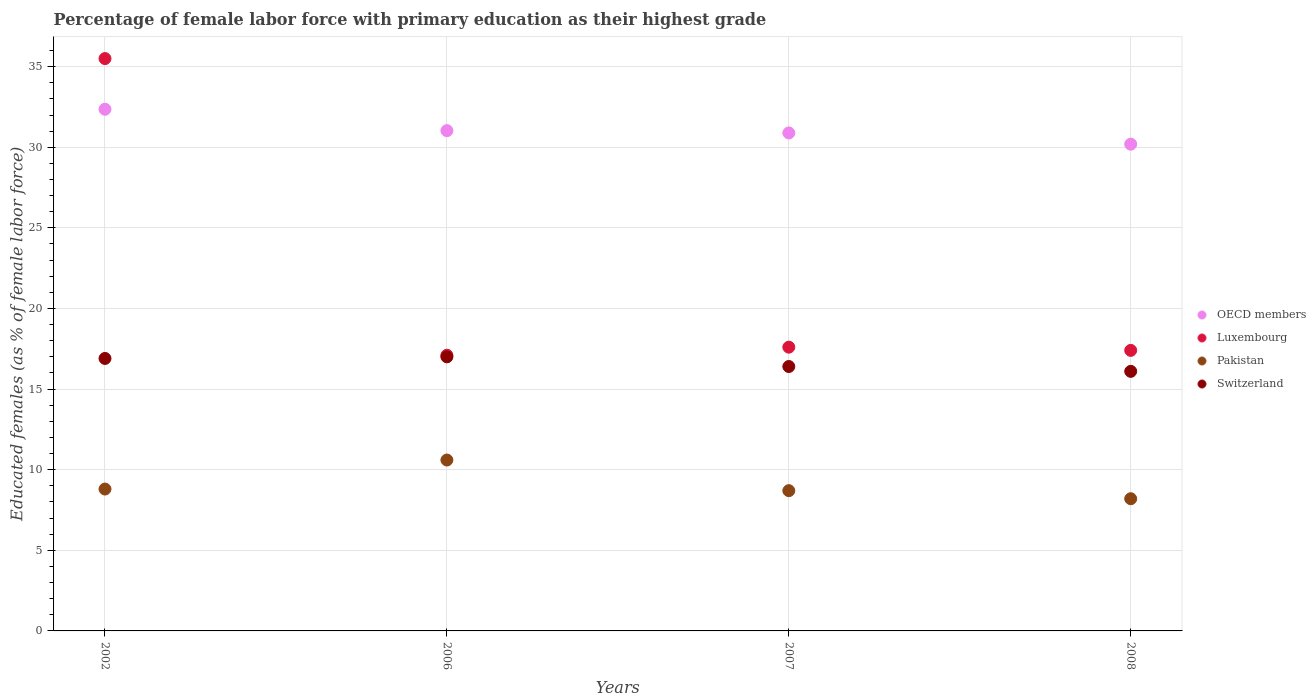What is the percentage of female labor force with primary education in Pakistan in 2006?
Make the answer very short. 10.6. Across all years, what is the maximum percentage of female labor force with primary education in Pakistan?
Your answer should be very brief. 10.6. Across all years, what is the minimum percentage of female labor force with primary education in Luxembourg?
Your response must be concise. 17.1. In which year was the percentage of female labor force with primary education in OECD members maximum?
Offer a terse response. 2002. What is the total percentage of female labor force with primary education in Switzerland in the graph?
Keep it short and to the point. 66.4. What is the difference between the percentage of female labor force with primary education in Pakistan in 2006 and that in 2008?
Keep it short and to the point. 2.4. What is the difference between the percentage of female labor force with primary education in OECD members in 2006 and the percentage of female labor force with primary education in Luxembourg in 2008?
Give a very brief answer. 13.63. What is the average percentage of female labor force with primary education in Luxembourg per year?
Make the answer very short. 21.9. In the year 2002, what is the difference between the percentage of female labor force with primary education in Pakistan and percentage of female labor force with primary education in Switzerland?
Offer a terse response. -8.1. In how many years, is the percentage of female labor force with primary education in OECD members greater than 18 %?
Your answer should be compact. 4. What is the ratio of the percentage of female labor force with primary education in OECD members in 2006 to that in 2007?
Make the answer very short. 1. Is the percentage of female labor force with primary education in Luxembourg in 2007 less than that in 2008?
Keep it short and to the point. No. What is the difference between the highest and the second highest percentage of female labor force with primary education in Switzerland?
Provide a succinct answer. 0.1. What is the difference between the highest and the lowest percentage of female labor force with primary education in OECD members?
Your answer should be very brief. 2.17. Is the percentage of female labor force with primary education in Pakistan strictly greater than the percentage of female labor force with primary education in Luxembourg over the years?
Provide a short and direct response. No. Is the percentage of female labor force with primary education in Luxembourg strictly less than the percentage of female labor force with primary education in Switzerland over the years?
Provide a short and direct response. No. How many dotlines are there?
Offer a very short reply. 4. How many years are there in the graph?
Provide a short and direct response. 4. What is the difference between two consecutive major ticks on the Y-axis?
Give a very brief answer. 5. Are the values on the major ticks of Y-axis written in scientific E-notation?
Offer a terse response. No. Does the graph contain any zero values?
Offer a terse response. No. Does the graph contain grids?
Give a very brief answer. Yes. What is the title of the graph?
Offer a terse response. Percentage of female labor force with primary education as their highest grade. What is the label or title of the Y-axis?
Provide a short and direct response. Educated females (as % of female labor force). What is the Educated females (as % of female labor force) in OECD members in 2002?
Provide a short and direct response. 32.36. What is the Educated females (as % of female labor force) in Luxembourg in 2002?
Your answer should be compact. 35.5. What is the Educated females (as % of female labor force) in Pakistan in 2002?
Offer a very short reply. 8.8. What is the Educated females (as % of female labor force) in Switzerland in 2002?
Your response must be concise. 16.9. What is the Educated females (as % of female labor force) of OECD members in 2006?
Ensure brevity in your answer.  31.03. What is the Educated females (as % of female labor force) in Luxembourg in 2006?
Offer a very short reply. 17.1. What is the Educated females (as % of female labor force) of Pakistan in 2006?
Your response must be concise. 10.6. What is the Educated females (as % of female labor force) in OECD members in 2007?
Give a very brief answer. 30.89. What is the Educated females (as % of female labor force) in Luxembourg in 2007?
Offer a very short reply. 17.6. What is the Educated females (as % of female labor force) of Pakistan in 2007?
Offer a very short reply. 8.7. What is the Educated females (as % of female labor force) of Switzerland in 2007?
Your answer should be compact. 16.4. What is the Educated females (as % of female labor force) of OECD members in 2008?
Give a very brief answer. 30.19. What is the Educated females (as % of female labor force) in Luxembourg in 2008?
Keep it short and to the point. 17.4. What is the Educated females (as % of female labor force) in Pakistan in 2008?
Your response must be concise. 8.2. What is the Educated females (as % of female labor force) in Switzerland in 2008?
Provide a succinct answer. 16.1. Across all years, what is the maximum Educated females (as % of female labor force) in OECD members?
Keep it short and to the point. 32.36. Across all years, what is the maximum Educated females (as % of female labor force) in Luxembourg?
Offer a terse response. 35.5. Across all years, what is the maximum Educated females (as % of female labor force) of Pakistan?
Provide a short and direct response. 10.6. Across all years, what is the maximum Educated females (as % of female labor force) of Switzerland?
Your response must be concise. 17. Across all years, what is the minimum Educated females (as % of female labor force) of OECD members?
Offer a very short reply. 30.19. Across all years, what is the minimum Educated females (as % of female labor force) in Luxembourg?
Your response must be concise. 17.1. Across all years, what is the minimum Educated females (as % of female labor force) of Pakistan?
Ensure brevity in your answer.  8.2. Across all years, what is the minimum Educated females (as % of female labor force) in Switzerland?
Offer a very short reply. 16.1. What is the total Educated females (as % of female labor force) of OECD members in the graph?
Ensure brevity in your answer.  124.47. What is the total Educated females (as % of female labor force) in Luxembourg in the graph?
Keep it short and to the point. 87.6. What is the total Educated females (as % of female labor force) in Pakistan in the graph?
Make the answer very short. 36.3. What is the total Educated females (as % of female labor force) of Switzerland in the graph?
Your answer should be compact. 66.4. What is the difference between the Educated females (as % of female labor force) of OECD members in 2002 and that in 2006?
Keep it short and to the point. 1.33. What is the difference between the Educated females (as % of female labor force) in Switzerland in 2002 and that in 2006?
Your answer should be very brief. -0.1. What is the difference between the Educated females (as % of female labor force) of OECD members in 2002 and that in 2007?
Your response must be concise. 1.47. What is the difference between the Educated females (as % of female labor force) of Pakistan in 2002 and that in 2007?
Give a very brief answer. 0.1. What is the difference between the Educated females (as % of female labor force) in Switzerland in 2002 and that in 2007?
Keep it short and to the point. 0.5. What is the difference between the Educated females (as % of female labor force) in OECD members in 2002 and that in 2008?
Offer a very short reply. 2.17. What is the difference between the Educated females (as % of female labor force) in Luxembourg in 2002 and that in 2008?
Provide a succinct answer. 18.1. What is the difference between the Educated females (as % of female labor force) of Switzerland in 2002 and that in 2008?
Keep it short and to the point. 0.8. What is the difference between the Educated females (as % of female labor force) of OECD members in 2006 and that in 2007?
Provide a short and direct response. 0.14. What is the difference between the Educated females (as % of female labor force) in Luxembourg in 2006 and that in 2007?
Provide a short and direct response. -0.5. What is the difference between the Educated females (as % of female labor force) of Pakistan in 2006 and that in 2007?
Provide a succinct answer. 1.9. What is the difference between the Educated females (as % of female labor force) in Switzerland in 2006 and that in 2007?
Offer a terse response. 0.6. What is the difference between the Educated females (as % of female labor force) of OECD members in 2006 and that in 2008?
Provide a succinct answer. 0.84. What is the difference between the Educated females (as % of female labor force) in Luxembourg in 2006 and that in 2008?
Your response must be concise. -0.3. What is the difference between the Educated females (as % of female labor force) of OECD members in 2007 and that in 2008?
Provide a succinct answer. 0.7. What is the difference between the Educated females (as % of female labor force) in Luxembourg in 2007 and that in 2008?
Give a very brief answer. 0.2. What is the difference between the Educated females (as % of female labor force) of Pakistan in 2007 and that in 2008?
Provide a short and direct response. 0.5. What is the difference between the Educated females (as % of female labor force) in OECD members in 2002 and the Educated females (as % of female labor force) in Luxembourg in 2006?
Offer a very short reply. 15.26. What is the difference between the Educated females (as % of female labor force) of OECD members in 2002 and the Educated females (as % of female labor force) of Pakistan in 2006?
Your response must be concise. 21.76. What is the difference between the Educated females (as % of female labor force) in OECD members in 2002 and the Educated females (as % of female labor force) in Switzerland in 2006?
Provide a short and direct response. 15.36. What is the difference between the Educated females (as % of female labor force) of Luxembourg in 2002 and the Educated females (as % of female labor force) of Pakistan in 2006?
Your answer should be compact. 24.9. What is the difference between the Educated females (as % of female labor force) of Luxembourg in 2002 and the Educated females (as % of female labor force) of Switzerland in 2006?
Your answer should be compact. 18.5. What is the difference between the Educated females (as % of female labor force) of Pakistan in 2002 and the Educated females (as % of female labor force) of Switzerland in 2006?
Ensure brevity in your answer.  -8.2. What is the difference between the Educated females (as % of female labor force) of OECD members in 2002 and the Educated females (as % of female labor force) of Luxembourg in 2007?
Make the answer very short. 14.76. What is the difference between the Educated females (as % of female labor force) of OECD members in 2002 and the Educated females (as % of female labor force) of Pakistan in 2007?
Your answer should be very brief. 23.66. What is the difference between the Educated females (as % of female labor force) of OECD members in 2002 and the Educated females (as % of female labor force) of Switzerland in 2007?
Make the answer very short. 15.96. What is the difference between the Educated females (as % of female labor force) in Luxembourg in 2002 and the Educated females (as % of female labor force) in Pakistan in 2007?
Your response must be concise. 26.8. What is the difference between the Educated females (as % of female labor force) in Pakistan in 2002 and the Educated females (as % of female labor force) in Switzerland in 2007?
Your response must be concise. -7.6. What is the difference between the Educated females (as % of female labor force) of OECD members in 2002 and the Educated females (as % of female labor force) of Luxembourg in 2008?
Your answer should be very brief. 14.96. What is the difference between the Educated females (as % of female labor force) of OECD members in 2002 and the Educated females (as % of female labor force) of Pakistan in 2008?
Ensure brevity in your answer.  24.16. What is the difference between the Educated females (as % of female labor force) in OECD members in 2002 and the Educated females (as % of female labor force) in Switzerland in 2008?
Your answer should be compact. 16.26. What is the difference between the Educated females (as % of female labor force) in Luxembourg in 2002 and the Educated females (as % of female labor force) in Pakistan in 2008?
Your response must be concise. 27.3. What is the difference between the Educated females (as % of female labor force) in Pakistan in 2002 and the Educated females (as % of female labor force) in Switzerland in 2008?
Keep it short and to the point. -7.3. What is the difference between the Educated females (as % of female labor force) in OECD members in 2006 and the Educated females (as % of female labor force) in Luxembourg in 2007?
Your response must be concise. 13.43. What is the difference between the Educated females (as % of female labor force) in OECD members in 2006 and the Educated females (as % of female labor force) in Pakistan in 2007?
Give a very brief answer. 22.33. What is the difference between the Educated females (as % of female labor force) of OECD members in 2006 and the Educated females (as % of female labor force) of Switzerland in 2007?
Make the answer very short. 14.63. What is the difference between the Educated females (as % of female labor force) in Luxembourg in 2006 and the Educated females (as % of female labor force) in Pakistan in 2007?
Offer a terse response. 8.4. What is the difference between the Educated females (as % of female labor force) in OECD members in 2006 and the Educated females (as % of female labor force) in Luxembourg in 2008?
Offer a terse response. 13.63. What is the difference between the Educated females (as % of female labor force) of OECD members in 2006 and the Educated females (as % of female labor force) of Pakistan in 2008?
Offer a very short reply. 22.83. What is the difference between the Educated females (as % of female labor force) of OECD members in 2006 and the Educated females (as % of female labor force) of Switzerland in 2008?
Provide a short and direct response. 14.93. What is the difference between the Educated females (as % of female labor force) of Luxembourg in 2006 and the Educated females (as % of female labor force) of Switzerland in 2008?
Give a very brief answer. 1. What is the difference between the Educated females (as % of female labor force) of Pakistan in 2006 and the Educated females (as % of female labor force) of Switzerland in 2008?
Keep it short and to the point. -5.5. What is the difference between the Educated females (as % of female labor force) of OECD members in 2007 and the Educated females (as % of female labor force) of Luxembourg in 2008?
Your answer should be compact. 13.49. What is the difference between the Educated females (as % of female labor force) in OECD members in 2007 and the Educated females (as % of female labor force) in Pakistan in 2008?
Provide a succinct answer. 22.69. What is the difference between the Educated females (as % of female labor force) in OECD members in 2007 and the Educated females (as % of female labor force) in Switzerland in 2008?
Give a very brief answer. 14.79. What is the difference between the Educated females (as % of female labor force) in Luxembourg in 2007 and the Educated females (as % of female labor force) in Switzerland in 2008?
Give a very brief answer. 1.5. What is the difference between the Educated females (as % of female labor force) in Pakistan in 2007 and the Educated females (as % of female labor force) in Switzerland in 2008?
Provide a succinct answer. -7.4. What is the average Educated females (as % of female labor force) in OECD members per year?
Offer a very short reply. 31.12. What is the average Educated females (as % of female labor force) in Luxembourg per year?
Your response must be concise. 21.9. What is the average Educated females (as % of female labor force) of Pakistan per year?
Offer a very short reply. 9.07. In the year 2002, what is the difference between the Educated females (as % of female labor force) in OECD members and Educated females (as % of female labor force) in Luxembourg?
Offer a terse response. -3.14. In the year 2002, what is the difference between the Educated females (as % of female labor force) in OECD members and Educated females (as % of female labor force) in Pakistan?
Make the answer very short. 23.56. In the year 2002, what is the difference between the Educated females (as % of female labor force) of OECD members and Educated females (as % of female labor force) of Switzerland?
Your response must be concise. 15.46. In the year 2002, what is the difference between the Educated females (as % of female labor force) of Luxembourg and Educated females (as % of female labor force) of Pakistan?
Make the answer very short. 26.7. In the year 2006, what is the difference between the Educated females (as % of female labor force) in OECD members and Educated females (as % of female labor force) in Luxembourg?
Your answer should be very brief. 13.93. In the year 2006, what is the difference between the Educated females (as % of female labor force) in OECD members and Educated females (as % of female labor force) in Pakistan?
Your answer should be compact. 20.43. In the year 2006, what is the difference between the Educated females (as % of female labor force) in OECD members and Educated females (as % of female labor force) in Switzerland?
Make the answer very short. 14.03. In the year 2006, what is the difference between the Educated females (as % of female labor force) in Luxembourg and Educated females (as % of female labor force) in Pakistan?
Provide a succinct answer. 6.5. In the year 2007, what is the difference between the Educated females (as % of female labor force) of OECD members and Educated females (as % of female labor force) of Luxembourg?
Provide a short and direct response. 13.29. In the year 2007, what is the difference between the Educated females (as % of female labor force) in OECD members and Educated females (as % of female labor force) in Pakistan?
Provide a succinct answer. 22.19. In the year 2007, what is the difference between the Educated females (as % of female labor force) in OECD members and Educated females (as % of female labor force) in Switzerland?
Your answer should be compact. 14.49. In the year 2007, what is the difference between the Educated females (as % of female labor force) in Luxembourg and Educated females (as % of female labor force) in Switzerland?
Provide a short and direct response. 1.2. In the year 2007, what is the difference between the Educated females (as % of female labor force) in Pakistan and Educated females (as % of female labor force) in Switzerland?
Make the answer very short. -7.7. In the year 2008, what is the difference between the Educated females (as % of female labor force) of OECD members and Educated females (as % of female labor force) of Luxembourg?
Keep it short and to the point. 12.79. In the year 2008, what is the difference between the Educated females (as % of female labor force) in OECD members and Educated females (as % of female labor force) in Pakistan?
Offer a terse response. 21.99. In the year 2008, what is the difference between the Educated females (as % of female labor force) in OECD members and Educated females (as % of female labor force) in Switzerland?
Keep it short and to the point. 14.09. In the year 2008, what is the difference between the Educated females (as % of female labor force) of Luxembourg and Educated females (as % of female labor force) of Pakistan?
Offer a very short reply. 9.2. In the year 2008, what is the difference between the Educated females (as % of female labor force) of Luxembourg and Educated females (as % of female labor force) of Switzerland?
Offer a terse response. 1.3. In the year 2008, what is the difference between the Educated females (as % of female labor force) in Pakistan and Educated females (as % of female labor force) in Switzerland?
Your response must be concise. -7.9. What is the ratio of the Educated females (as % of female labor force) of OECD members in 2002 to that in 2006?
Keep it short and to the point. 1.04. What is the ratio of the Educated females (as % of female labor force) in Luxembourg in 2002 to that in 2006?
Keep it short and to the point. 2.08. What is the ratio of the Educated females (as % of female labor force) in Pakistan in 2002 to that in 2006?
Your response must be concise. 0.83. What is the ratio of the Educated females (as % of female labor force) of OECD members in 2002 to that in 2007?
Give a very brief answer. 1.05. What is the ratio of the Educated females (as % of female labor force) of Luxembourg in 2002 to that in 2007?
Your answer should be compact. 2.02. What is the ratio of the Educated females (as % of female labor force) of Pakistan in 2002 to that in 2007?
Provide a succinct answer. 1.01. What is the ratio of the Educated females (as % of female labor force) in Switzerland in 2002 to that in 2007?
Keep it short and to the point. 1.03. What is the ratio of the Educated females (as % of female labor force) of OECD members in 2002 to that in 2008?
Make the answer very short. 1.07. What is the ratio of the Educated females (as % of female labor force) in Luxembourg in 2002 to that in 2008?
Your answer should be compact. 2.04. What is the ratio of the Educated females (as % of female labor force) of Pakistan in 2002 to that in 2008?
Your response must be concise. 1.07. What is the ratio of the Educated females (as % of female labor force) in Switzerland in 2002 to that in 2008?
Your response must be concise. 1.05. What is the ratio of the Educated females (as % of female labor force) in Luxembourg in 2006 to that in 2007?
Ensure brevity in your answer.  0.97. What is the ratio of the Educated females (as % of female labor force) in Pakistan in 2006 to that in 2007?
Offer a terse response. 1.22. What is the ratio of the Educated females (as % of female labor force) of Switzerland in 2006 to that in 2007?
Ensure brevity in your answer.  1.04. What is the ratio of the Educated females (as % of female labor force) of OECD members in 2006 to that in 2008?
Offer a very short reply. 1.03. What is the ratio of the Educated females (as % of female labor force) of Luxembourg in 2006 to that in 2008?
Your response must be concise. 0.98. What is the ratio of the Educated females (as % of female labor force) in Pakistan in 2006 to that in 2008?
Provide a succinct answer. 1.29. What is the ratio of the Educated females (as % of female labor force) in Switzerland in 2006 to that in 2008?
Keep it short and to the point. 1.06. What is the ratio of the Educated females (as % of female labor force) in OECD members in 2007 to that in 2008?
Keep it short and to the point. 1.02. What is the ratio of the Educated females (as % of female labor force) of Luxembourg in 2007 to that in 2008?
Keep it short and to the point. 1.01. What is the ratio of the Educated females (as % of female labor force) of Pakistan in 2007 to that in 2008?
Your response must be concise. 1.06. What is the ratio of the Educated females (as % of female labor force) of Switzerland in 2007 to that in 2008?
Offer a terse response. 1.02. What is the difference between the highest and the second highest Educated females (as % of female labor force) in OECD members?
Provide a short and direct response. 1.33. What is the difference between the highest and the lowest Educated females (as % of female labor force) of OECD members?
Offer a very short reply. 2.17. What is the difference between the highest and the lowest Educated females (as % of female labor force) of Pakistan?
Offer a terse response. 2.4. 